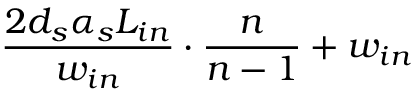Convert formula to latex. <formula><loc_0><loc_0><loc_500><loc_500>\frac { 2 d _ { s } \alpha _ { s } L _ { i n } } { w _ { i n } } \cdot \frac { n } { n - 1 } + w _ { i n }</formula> 